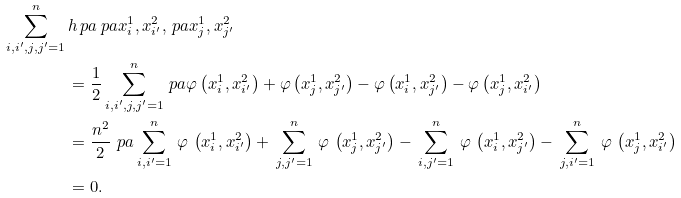<formula> <loc_0><loc_0><loc_500><loc_500>\sum _ { i , i ^ { \prime } , j , j ^ { \prime } = 1 } ^ { n } \, & h \ p a { \ p a { x _ { i } ^ { 1 } , x _ { i ^ { \prime } } ^ { 2 } } , \ p a { x _ { j } ^ { 1 } , x _ { j ^ { \prime } } ^ { 2 } } } \\ & = \frac { 1 } { 2 } \sum _ { i , i ^ { \prime } , j , j ^ { \prime } = 1 } ^ { n } \ p a { \varphi \left ( x _ { i } ^ { 1 } , x _ { i ^ { \prime } } ^ { 2 } \right ) + \varphi \left ( x _ { j } ^ { 1 } , x _ { j ^ { \prime } } ^ { 2 } \right ) - \varphi \left ( x _ { i } ^ { 1 } , x _ { j ^ { \prime } } ^ { 2 } \right ) - \varphi \left ( x _ { j } ^ { 1 } , x _ { i ^ { \prime } } ^ { 2 } \right ) } \\ & = \frac { n ^ { 2 } } { 2 } \, \ p a { \, \sum _ { i , i ^ { \prime } = 1 } ^ { n } \, \varphi \, \left ( x _ { i } ^ { 1 } , x _ { i ^ { \prime } } ^ { 2 } \right ) + \, \sum _ { j , j ^ { \prime } = 1 } ^ { n } \, \varphi \, \left ( x _ { j } ^ { 1 } , x _ { j ^ { \prime } } ^ { 2 } \right ) - \, \sum _ { i , j ^ { \prime } = 1 } ^ { n } \, \varphi \, \left ( x _ { i } ^ { 1 } , x _ { j ^ { \prime } } ^ { 2 } \right ) - \, \sum _ { j , i ^ { \prime } = 1 } ^ { n } \, \varphi \, \left ( x _ { j } ^ { 1 } , x _ { i ^ { \prime } } ^ { 2 } \right ) \, } \\ & = 0 .</formula> 